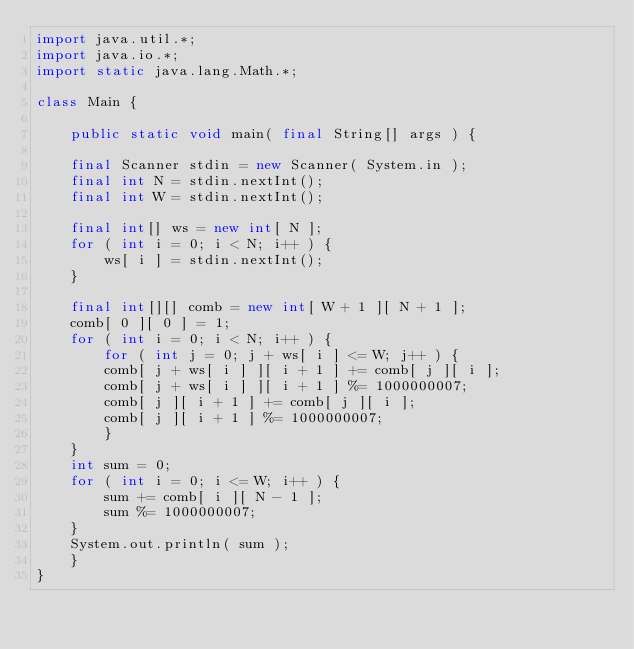Convert code to text. <code><loc_0><loc_0><loc_500><loc_500><_Java_>import java.util.*;
import java.io.*;
import static java.lang.Math.*;

class Main {

    public static void main( final String[] args ) {

	final Scanner stdin = new Scanner( System.in );
	final int N = stdin.nextInt();
	final int W = stdin.nextInt();

	final int[] ws = new int[ N ];
	for ( int i = 0; i < N; i++ ) {
	    ws[ i ] = stdin.nextInt();
	}

	final int[][] comb = new int[ W + 1 ][ N + 1 ];
	comb[ 0 ][ 0 ] = 1;
	for ( int i = 0; i < N; i++ ) {
	    for ( int j = 0; j + ws[ i ] <= W; j++ ) {
		comb[ j + ws[ i ] ][ i + 1 ] += comb[ j ][ i ];
		comb[ j + ws[ i ] ][ i + 1 ] %= 1000000007;
		comb[ j ][ i + 1 ] += comb[ j ][ i ];
		comb[ j ][ i + 1 ] %= 1000000007;
	    }
	}
	int sum = 0;
	for ( int i = 0; i <= W; i++ ) {
	    sum += comb[ i ][ N - 1 ];
	    sum %= 1000000007;
	}
	System.out.println( sum );
    }    
}</code> 